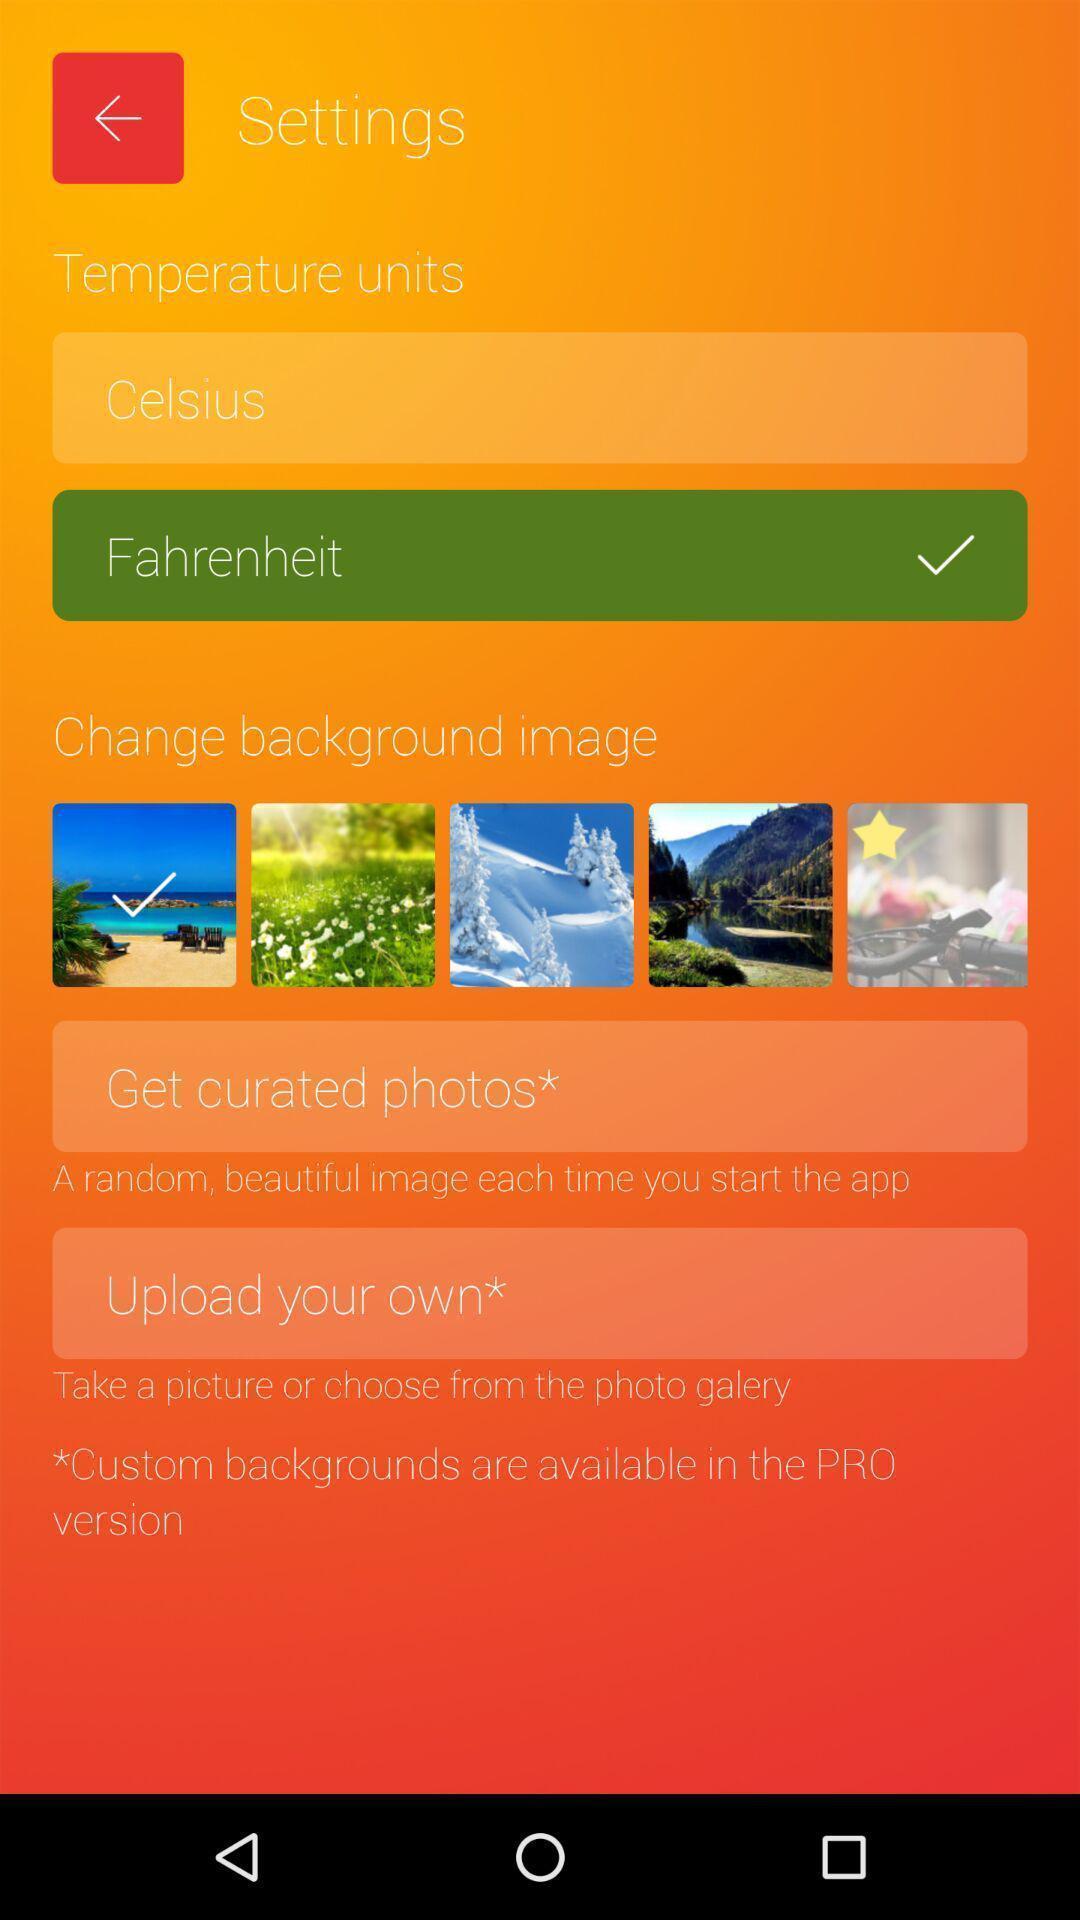Describe the visual elements of this screenshot. Page displaying with list of different settings. 